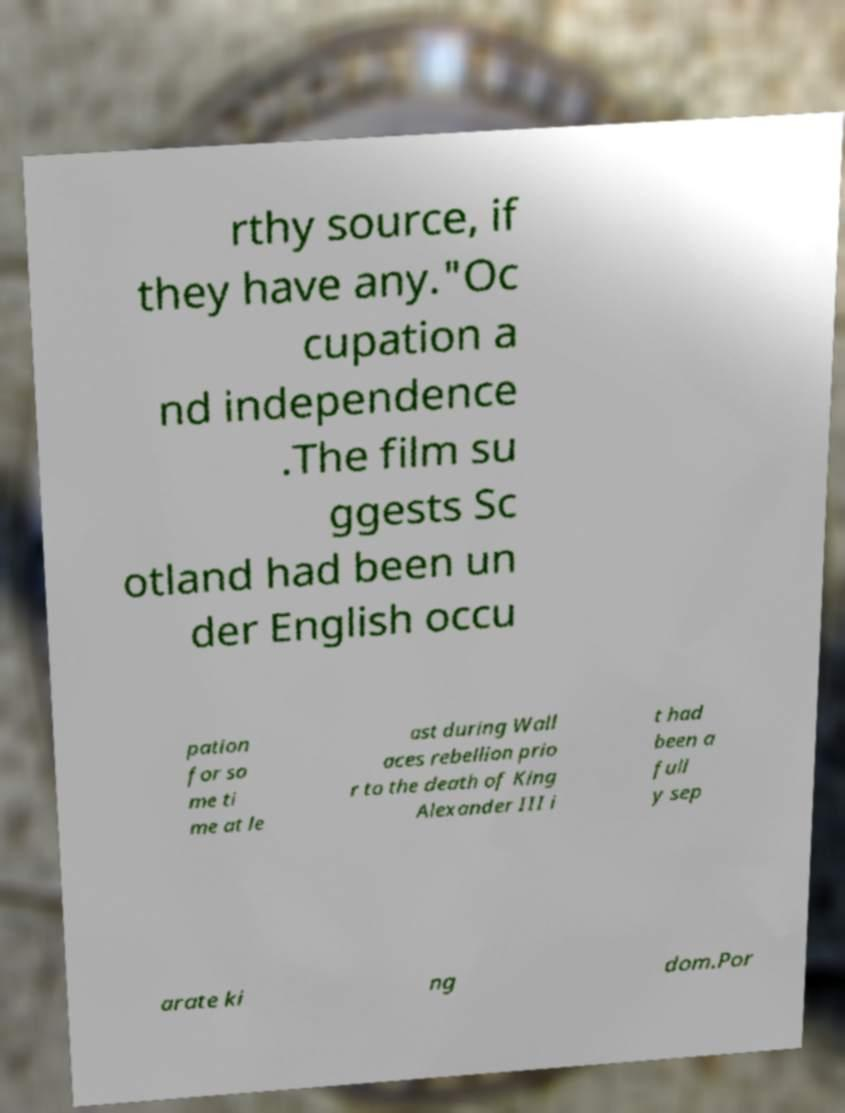Please read and relay the text visible in this image. What does it say? rthy source, if they have any."Oc cupation a nd independence .The film su ggests Sc otland had been un der English occu pation for so me ti me at le ast during Wall aces rebellion prio r to the death of King Alexander III i t had been a full y sep arate ki ng dom.Por 